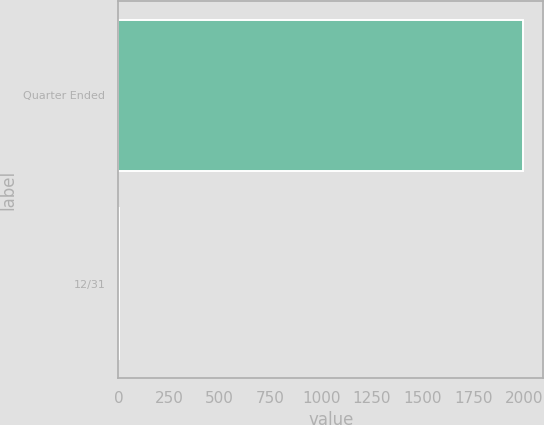<chart> <loc_0><loc_0><loc_500><loc_500><bar_chart><fcel>Quarter Ended<fcel>12/31<nl><fcel>1997<fcel>0.45<nl></chart> 